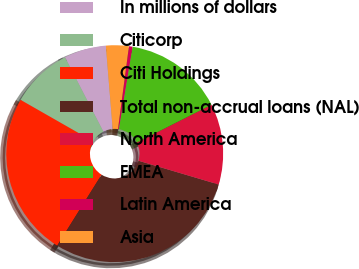Convert chart. <chart><loc_0><loc_0><loc_500><loc_500><pie_chart><fcel>In millions of dollars<fcel>Citicorp<fcel>Citi Holdings<fcel>Total non-accrual loans (NAL)<fcel>North America<fcel>EMEA<fcel>Latin America<fcel>Asia<nl><fcel>6.28%<fcel>9.16%<fcel>24.37%<fcel>29.31%<fcel>12.04%<fcel>14.92%<fcel>0.53%<fcel>3.4%<nl></chart> 